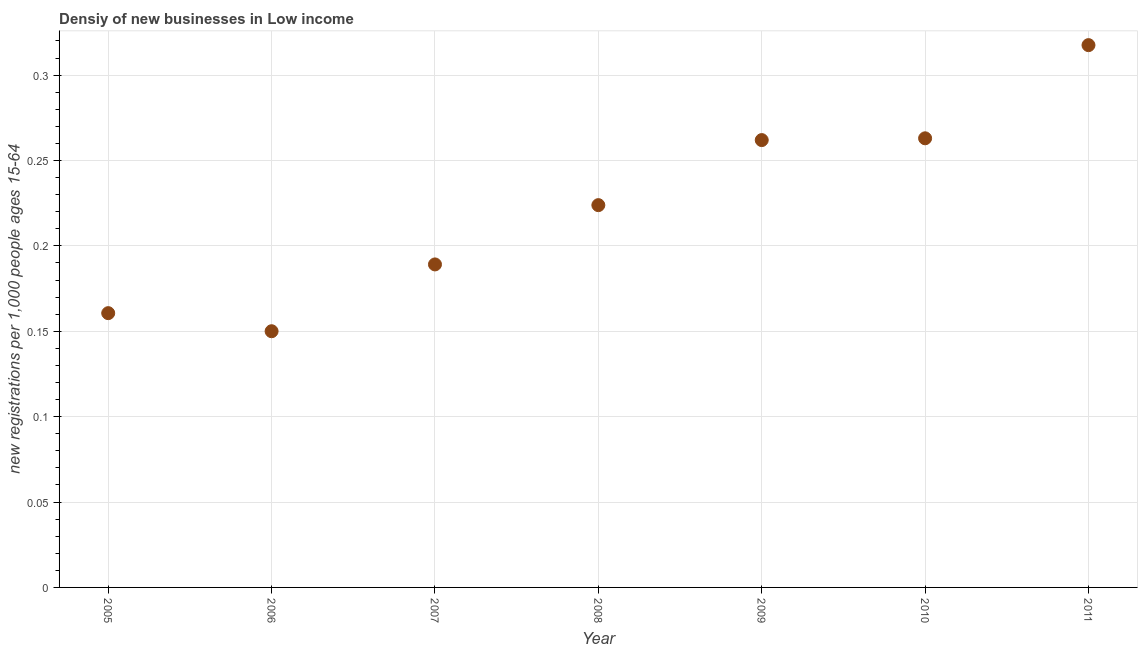What is the density of new business in 2005?
Provide a short and direct response. 0.16. Across all years, what is the maximum density of new business?
Give a very brief answer. 0.32. Across all years, what is the minimum density of new business?
Offer a terse response. 0.15. What is the sum of the density of new business?
Provide a short and direct response. 1.57. What is the difference between the density of new business in 2008 and 2011?
Your answer should be compact. -0.09. What is the average density of new business per year?
Give a very brief answer. 0.22. What is the median density of new business?
Offer a very short reply. 0.22. In how many years, is the density of new business greater than 0.1 ?
Keep it short and to the point. 7. What is the ratio of the density of new business in 2007 to that in 2010?
Provide a short and direct response. 0.72. What is the difference between the highest and the second highest density of new business?
Provide a short and direct response. 0.05. What is the difference between the highest and the lowest density of new business?
Your answer should be very brief. 0.17. Does the density of new business monotonically increase over the years?
Your response must be concise. No. How many years are there in the graph?
Your answer should be very brief. 7. What is the title of the graph?
Make the answer very short. Densiy of new businesses in Low income. What is the label or title of the X-axis?
Your response must be concise. Year. What is the label or title of the Y-axis?
Your response must be concise. New registrations per 1,0 people ages 15-64. What is the new registrations per 1,000 people ages 15-64 in 2005?
Your answer should be very brief. 0.16. What is the new registrations per 1,000 people ages 15-64 in 2006?
Your response must be concise. 0.15. What is the new registrations per 1,000 people ages 15-64 in 2007?
Ensure brevity in your answer.  0.19. What is the new registrations per 1,000 people ages 15-64 in 2008?
Make the answer very short. 0.22. What is the new registrations per 1,000 people ages 15-64 in 2009?
Make the answer very short. 0.26. What is the new registrations per 1,000 people ages 15-64 in 2010?
Give a very brief answer. 0.26. What is the new registrations per 1,000 people ages 15-64 in 2011?
Your answer should be compact. 0.32. What is the difference between the new registrations per 1,000 people ages 15-64 in 2005 and 2006?
Make the answer very short. 0.01. What is the difference between the new registrations per 1,000 people ages 15-64 in 2005 and 2007?
Give a very brief answer. -0.03. What is the difference between the new registrations per 1,000 people ages 15-64 in 2005 and 2008?
Provide a succinct answer. -0.06. What is the difference between the new registrations per 1,000 people ages 15-64 in 2005 and 2009?
Your answer should be very brief. -0.1. What is the difference between the new registrations per 1,000 people ages 15-64 in 2005 and 2010?
Ensure brevity in your answer.  -0.1. What is the difference between the new registrations per 1,000 people ages 15-64 in 2005 and 2011?
Make the answer very short. -0.16. What is the difference between the new registrations per 1,000 people ages 15-64 in 2006 and 2007?
Your answer should be very brief. -0.04. What is the difference between the new registrations per 1,000 people ages 15-64 in 2006 and 2008?
Your answer should be very brief. -0.07. What is the difference between the new registrations per 1,000 people ages 15-64 in 2006 and 2009?
Ensure brevity in your answer.  -0.11. What is the difference between the new registrations per 1,000 people ages 15-64 in 2006 and 2010?
Your answer should be compact. -0.11. What is the difference between the new registrations per 1,000 people ages 15-64 in 2006 and 2011?
Ensure brevity in your answer.  -0.17. What is the difference between the new registrations per 1,000 people ages 15-64 in 2007 and 2008?
Offer a very short reply. -0.03. What is the difference between the new registrations per 1,000 people ages 15-64 in 2007 and 2009?
Offer a terse response. -0.07. What is the difference between the new registrations per 1,000 people ages 15-64 in 2007 and 2010?
Give a very brief answer. -0.07. What is the difference between the new registrations per 1,000 people ages 15-64 in 2007 and 2011?
Your response must be concise. -0.13. What is the difference between the new registrations per 1,000 people ages 15-64 in 2008 and 2009?
Provide a succinct answer. -0.04. What is the difference between the new registrations per 1,000 people ages 15-64 in 2008 and 2010?
Your answer should be compact. -0.04. What is the difference between the new registrations per 1,000 people ages 15-64 in 2008 and 2011?
Provide a succinct answer. -0.09. What is the difference between the new registrations per 1,000 people ages 15-64 in 2009 and 2010?
Provide a short and direct response. -0. What is the difference between the new registrations per 1,000 people ages 15-64 in 2009 and 2011?
Your answer should be very brief. -0.06. What is the difference between the new registrations per 1,000 people ages 15-64 in 2010 and 2011?
Your answer should be compact. -0.05. What is the ratio of the new registrations per 1,000 people ages 15-64 in 2005 to that in 2006?
Offer a very short reply. 1.07. What is the ratio of the new registrations per 1,000 people ages 15-64 in 2005 to that in 2007?
Your answer should be very brief. 0.85. What is the ratio of the new registrations per 1,000 people ages 15-64 in 2005 to that in 2008?
Your answer should be very brief. 0.72. What is the ratio of the new registrations per 1,000 people ages 15-64 in 2005 to that in 2009?
Your answer should be compact. 0.61. What is the ratio of the new registrations per 1,000 people ages 15-64 in 2005 to that in 2010?
Give a very brief answer. 0.61. What is the ratio of the new registrations per 1,000 people ages 15-64 in 2005 to that in 2011?
Your response must be concise. 0.51. What is the ratio of the new registrations per 1,000 people ages 15-64 in 2006 to that in 2007?
Keep it short and to the point. 0.79. What is the ratio of the new registrations per 1,000 people ages 15-64 in 2006 to that in 2008?
Provide a succinct answer. 0.67. What is the ratio of the new registrations per 1,000 people ages 15-64 in 2006 to that in 2009?
Provide a short and direct response. 0.57. What is the ratio of the new registrations per 1,000 people ages 15-64 in 2006 to that in 2010?
Offer a very short reply. 0.57. What is the ratio of the new registrations per 1,000 people ages 15-64 in 2006 to that in 2011?
Offer a very short reply. 0.47. What is the ratio of the new registrations per 1,000 people ages 15-64 in 2007 to that in 2008?
Keep it short and to the point. 0.84. What is the ratio of the new registrations per 1,000 people ages 15-64 in 2007 to that in 2009?
Give a very brief answer. 0.72. What is the ratio of the new registrations per 1,000 people ages 15-64 in 2007 to that in 2010?
Offer a terse response. 0.72. What is the ratio of the new registrations per 1,000 people ages 15-64 in 2007 to that in 2011?
Your response must be concise. 0.6. What is the ratio of the new registrations per 1,000 people ages 15-64 in 2008 to that in 2009?
Give a very brief answer. 0.85. What is the ratio of the new registrations per 1,000 people ages 15-64 in 2008 to that in 2010?
Offer a terse response. 0.85. What is the ratio of the new registrations per 1,000 people ages 15-64 in 2008 to that in 2011?
Your answer should be compact. 0.7. What is the ratio of the new registrations per 1,000 people ages 15-64 in 2009 to that in 2011?
Ensure brevity in your answer.  0.82. What is the ratio of the new registrations per 1,000 people ages 15-64 in 2010 to that in 2011?
Provide a succinct answer. 0.83. 